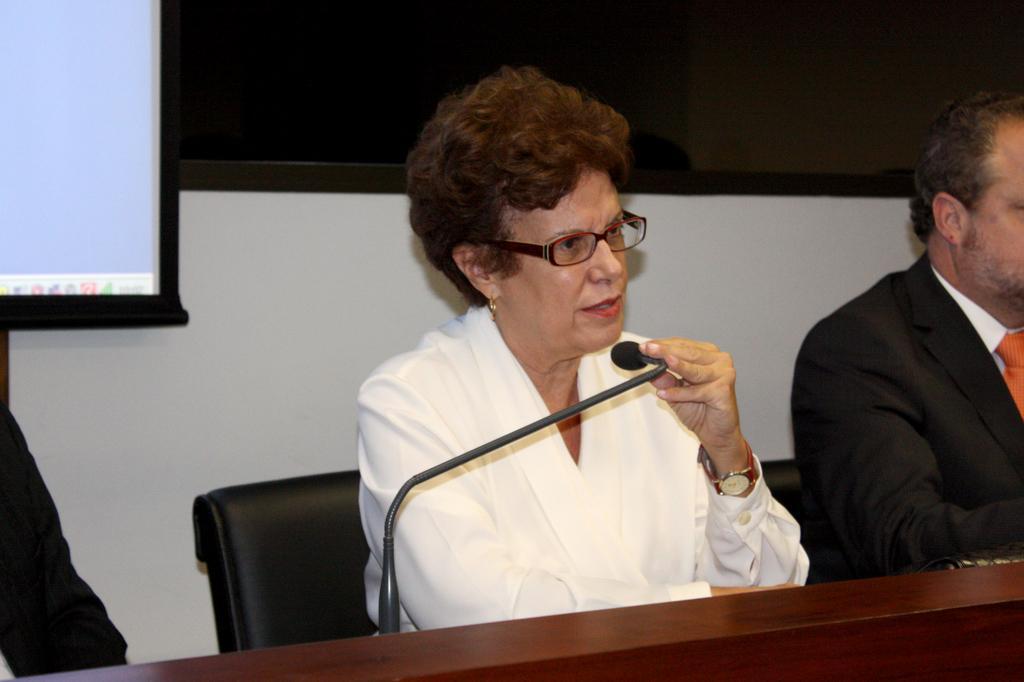How would you summarize this image in a sentence or two? In this picture we can see a woman sitting on the chair and holding mike, side we can see few people are sitting, behind we can see a board to the wall. 